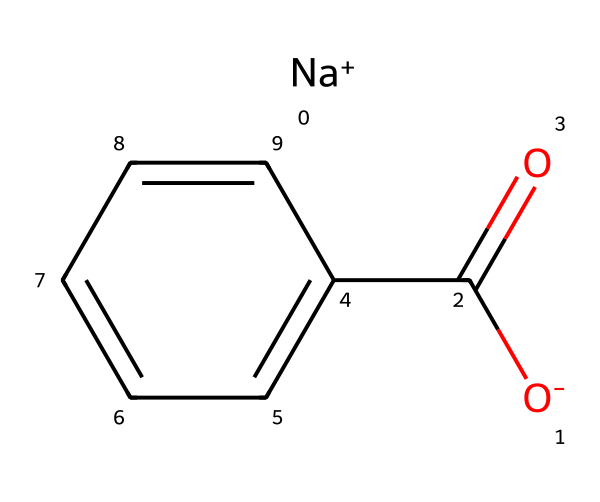What is the molecular formula of sodium benzoate? By analyzing the structure represented by the SMILES notation, we can identify the individual components: sodium (Na), carbon (C), hydrogen (H), and oxygen (O). Counting them gives us C7H5O2Na.
Answer: C7H5O2Na How many carbon atoms are present in sodium benzoate? From the structure, we can see there are 7 carbon atoms in total, as represented in the arrangement of the benzene ring and the carboxyl group.
Answer: 7 What functional group is present in sodium benzoate? The carboxyl group (-COOH) is identified in the structure, which is characteristic of carboxylic acids and their derivatives.
Answer: carboxyl How many hydrogen atoms are in sodium benzoate? By reviewing the structure, we can see that there are 5 hydrogen atoms attached to the carbon atoms in the benzene ring and the carboxyl group.
Answer: 5 What type of compound is sodium benzoate classified as? Given its structure, sodium benzoate fits the classification of a salt, specifically a sodium salt of benzoic acid, which contains a sodium ion and a benzoate anion.
Answer: salt What is the charge of the sodium ion in sodium benzoate? The sodium ion (Na+) is indicated in the structure as positively charged, providing the ionic character of the compound.
Answer: +1 Is sodium benzoate a natural or synthetic preservative? Sodium benzoate can be derived from benzoic acid, which occurs naturally in some fruits but is often produced synthetically for use as a food preservative.
Answer: both 